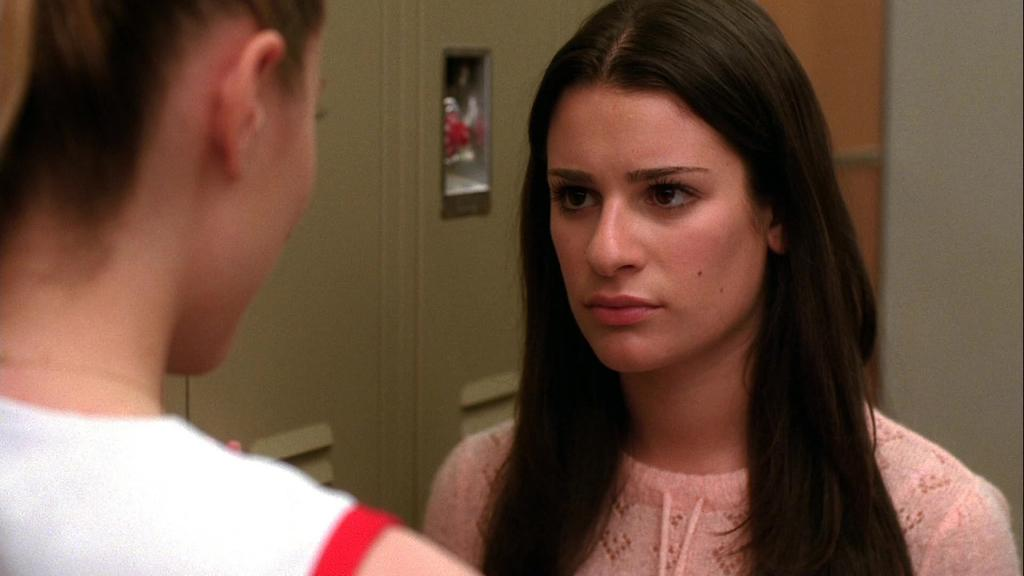How many women are in the image? There are two women in the foreground of the image. What are the women doing in the image? The women are facing each other. What can be seen in the background of the image? There is a wall and a cupboard in the background of the image. What type of decision can be seen being made by the snail in the image? There is no snail present in the image, so no decision can be observed. What type of machine is visible in the image? There is no machine visible in the image. 